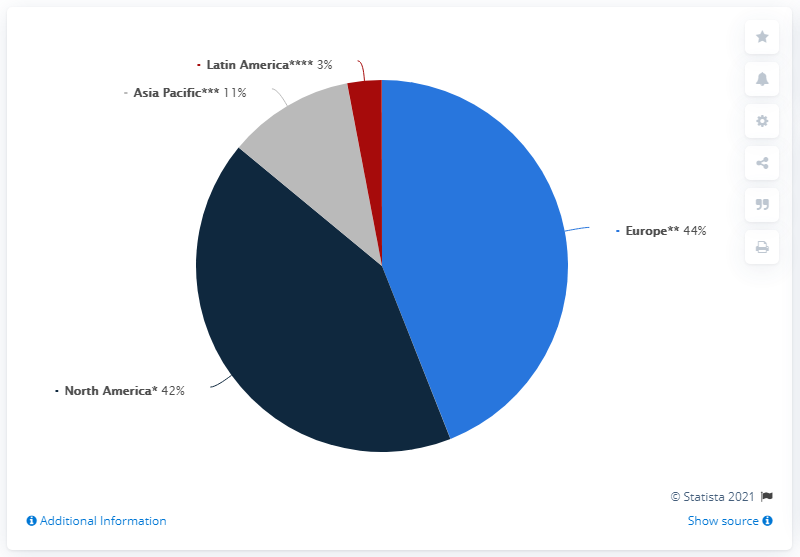Give some essential details in this illustration. In 2019, Tommy Hilfiger's retail sales in Europe accounted for approximately 44% of the company's total retail sales. In 2019, the share of Tommy Hilfiger retail sales in Europe was 33%, while the share in Asia Pacific was 33%. 